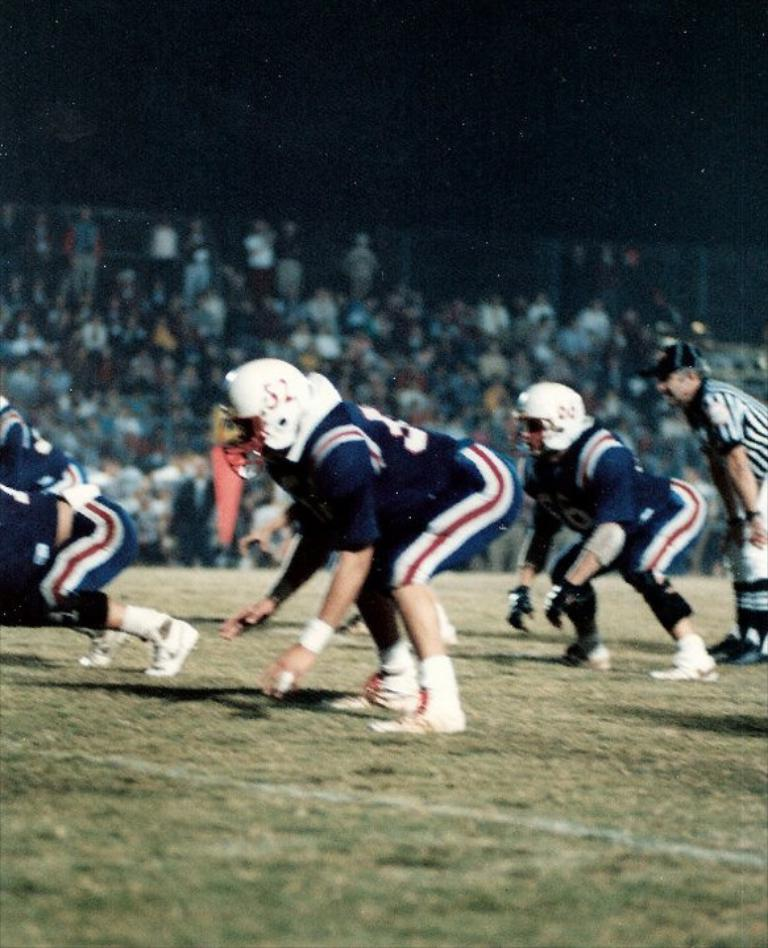Who or what can be seen in the image? There are people in the image. What is the position of the people in the image? The people are on the ground. Can you describe the background of the image? The background of the image is blurred. What type of shoe is the person wearing in the image? There is no information about shoes or footwear in the image, as the focus is on the people and their position on the ground. 